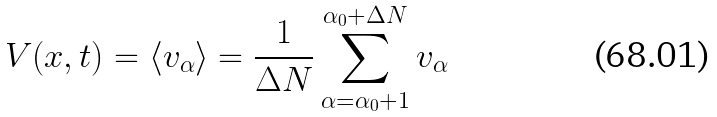<formula> <loc_0><loc_0><loc_500><loc_500>V ( x , t ) = \langle v _ { \alpha } \rangle = \frac { 1 } { \Delta N } \sum _ { \alpha = \alpha _ { 0 } + 1 } ^ { \alpha _ { 0 } + \Delta N } v _ { \alpha }</formula> 